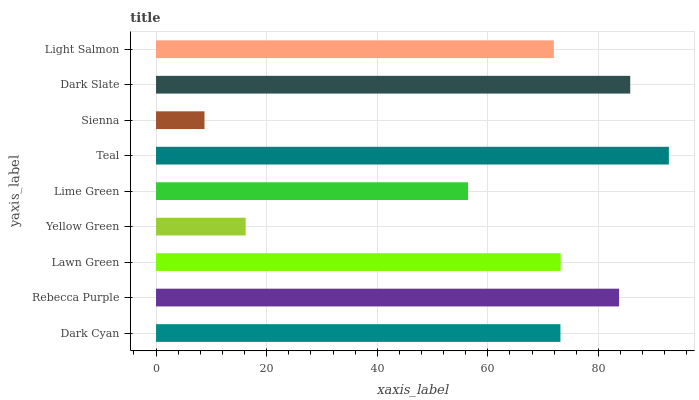Is Sienna the minimum?
Answer yes or no. Yes. Is Teal the maximum?
Answer yes or no. Yes. Is Rebecca Purple the minimum?
Answer yes or no. No. Is Rebecca Purple the maximum?
Answer yes or no. No. Is Rebecca Purple greater than Dark Cyan?
Answer yes or no. Yes. Is Dark Cyan less than Rebecca Purple?
Answer yes or no. Yes. Is Dark Cyan greater than Rebecca Purple?
Answer yes or no. No. Is Rebecca Purple less than Dark Cyan?
Answer yes or no. No. Is Dark Cyan the high median?
Answer yes or no. Yes. Is Dark Cyan the low median?
Answer yes or no. Yes. Is Light Salmon the high median?
Answer yes or no. No. Is Sienna the low median?
Answer yes or no. No. 